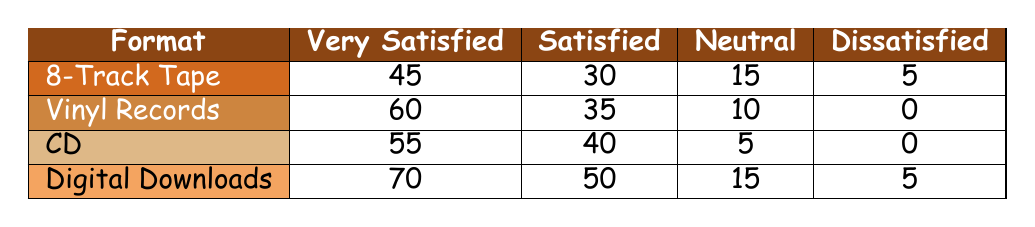How many customers rated 8-track tapes as "Very Satisfied"? The table shows that 45 customers rated 8-track tapes as "Very Satisfied."
Answer: 45 Which format received the highest number of "Dissatisfied" ratings? The table indicates that both Vinyl Records and CD formats received 0 "Dissatisfied" ratings, while 8-track tapes and Digital Downloads had 5 each, making them tied for the highest number among all.
Answer: 8-track tapes and Digital Downloads What is the total count of customers who are "Satisfied" with CD as a format? According to the table, the count of customers who are "Satisfied" with CD is 40.
Answer: 40 How does the number of "Very Satisfied" ratings for Digital Downloads compare to that of 8-track tapes? Digital Downloads have 70 "Very Satisfied" ratings, while 8-track tapes have 45 "Very Satisfied" ratings. 70 is greater than 45, indicating that Digital Downloads are preferred in this category.
Answer: 70 is greater than 45 What percentage of the 8-track tape customers rated it as "Neutral"? The count of customers rating 8-track tapes as "Neutral" is 15 out of a total of 95 customers (45 + 30 + 15 + 5). The calculation is (15/95) * 100 = 15.79, which rounds to approximately 16%.
Answer: 16% 